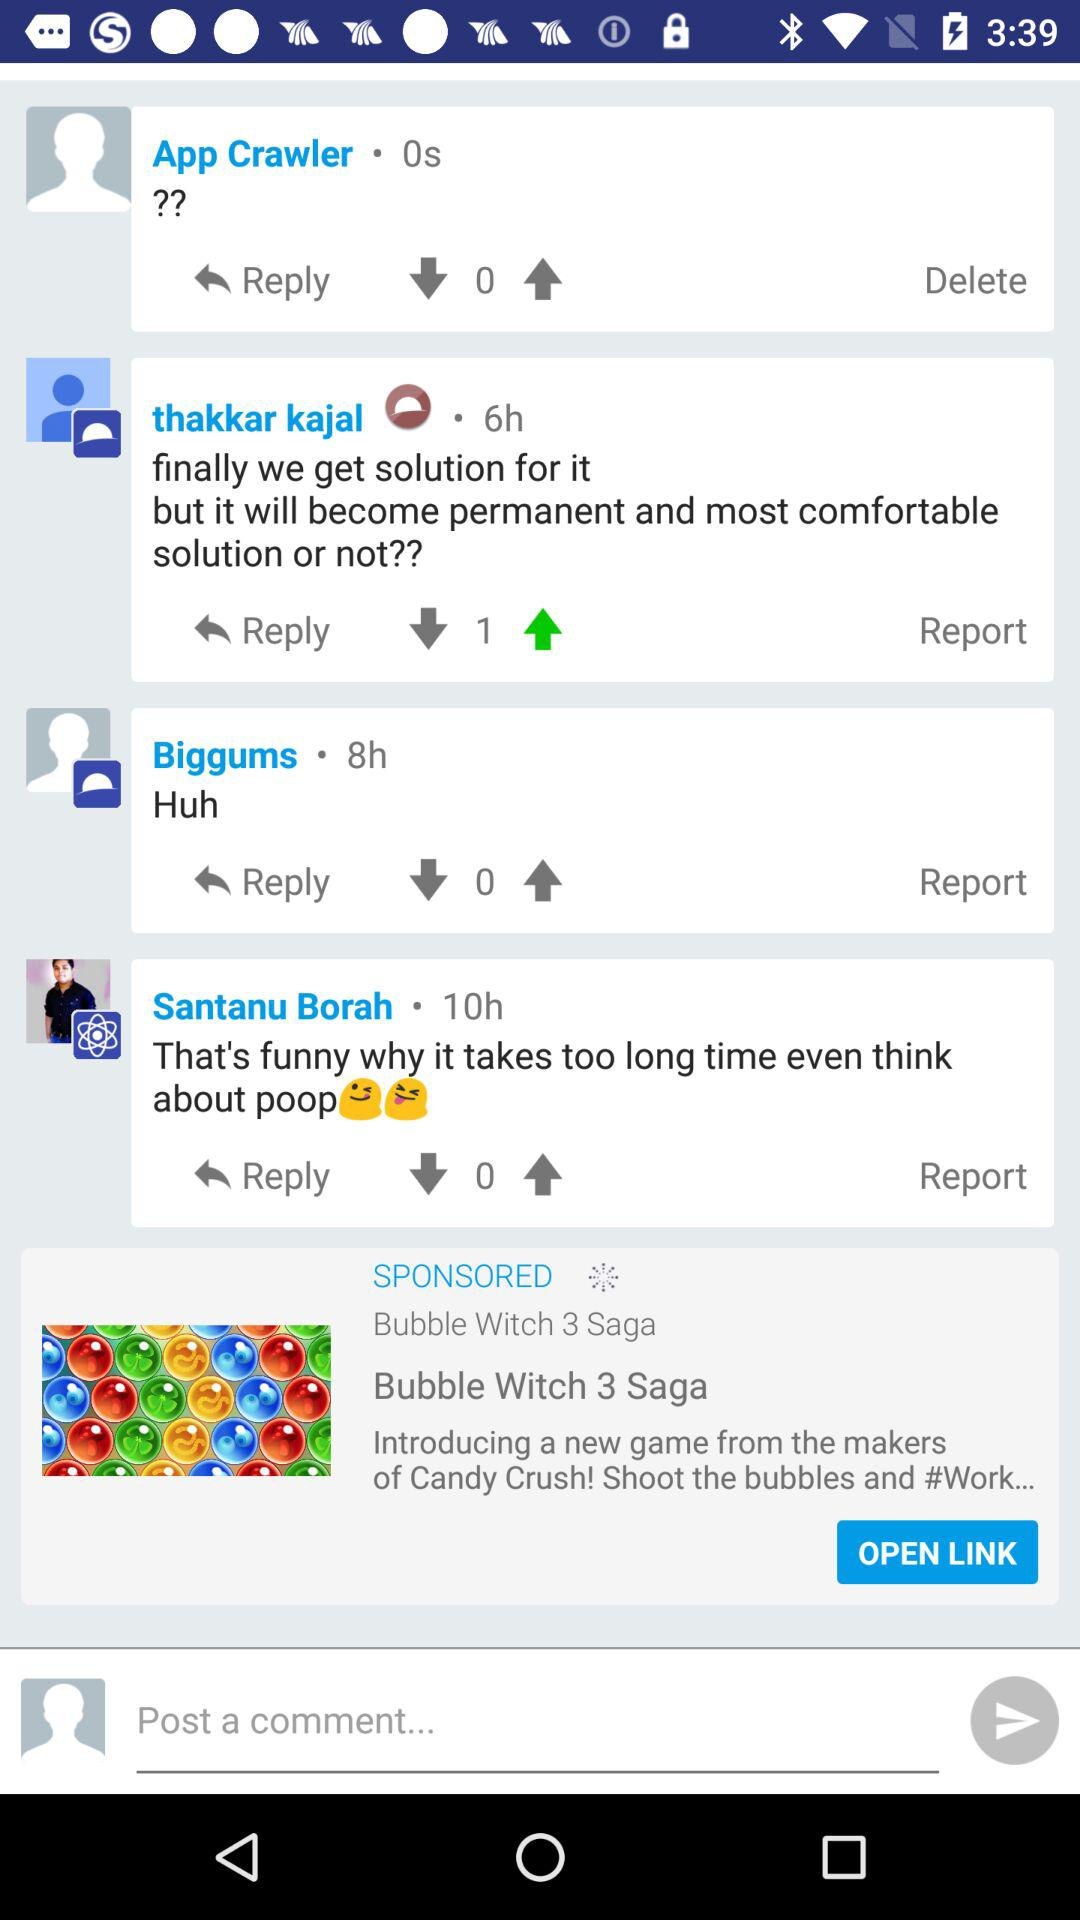How many comments are there on this page?
Answer the question using a single word or phrase. 4 